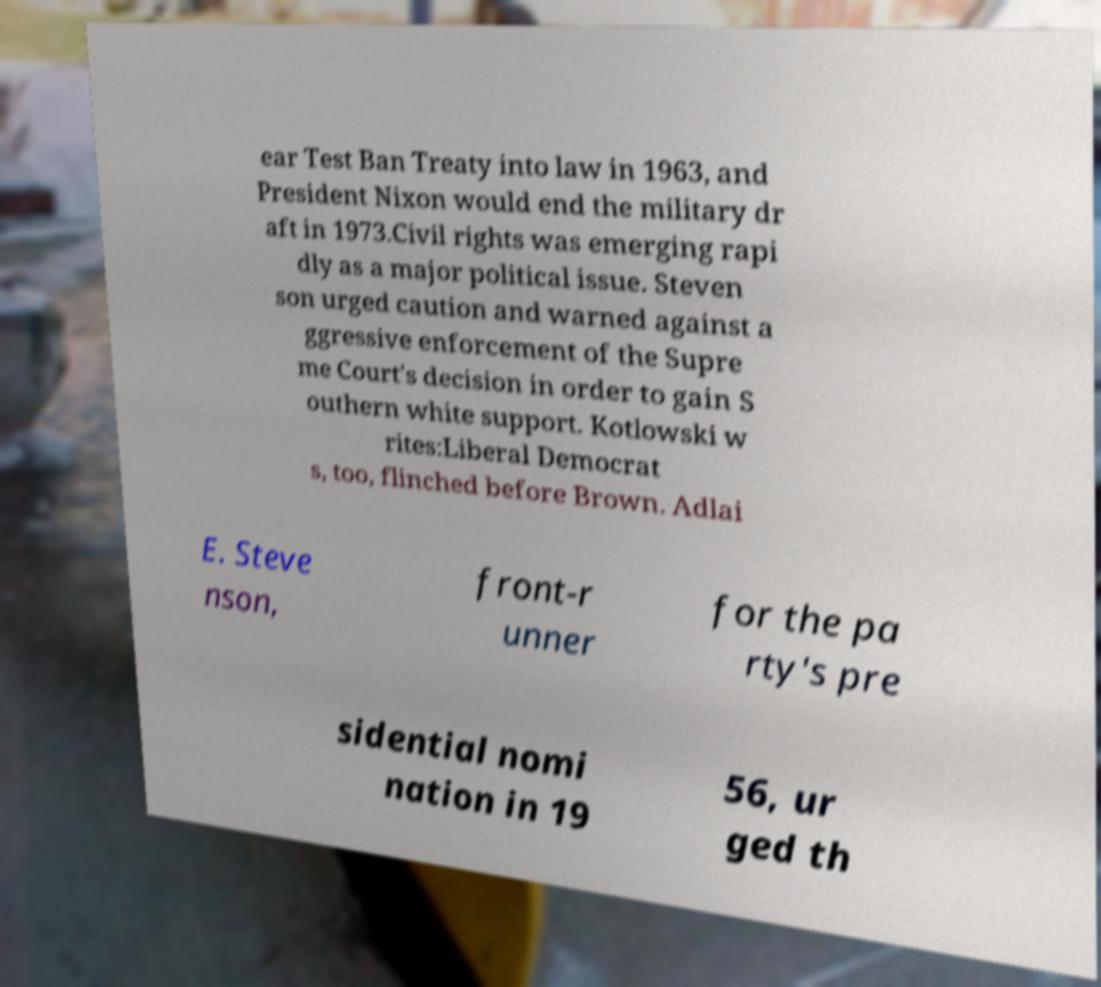Please identify and transcribe the text found in this image. ear Test Ban Treaty into law in 1963, and President Nixon would end the military dr aft in 1973.Civil rights was emerging rapi dly as a major political issue. Steven son urged caution and warned against a ggressive enforcement of the Supre me Court's decision in order to gain S outhern white support. Kotlowski w rites:Liberal Democrat s, too, flinched before Brown. Adlai E. Steve nson, front-r unner for the pa rty's pre sidential nomi nation in 19 56, ur ged th 